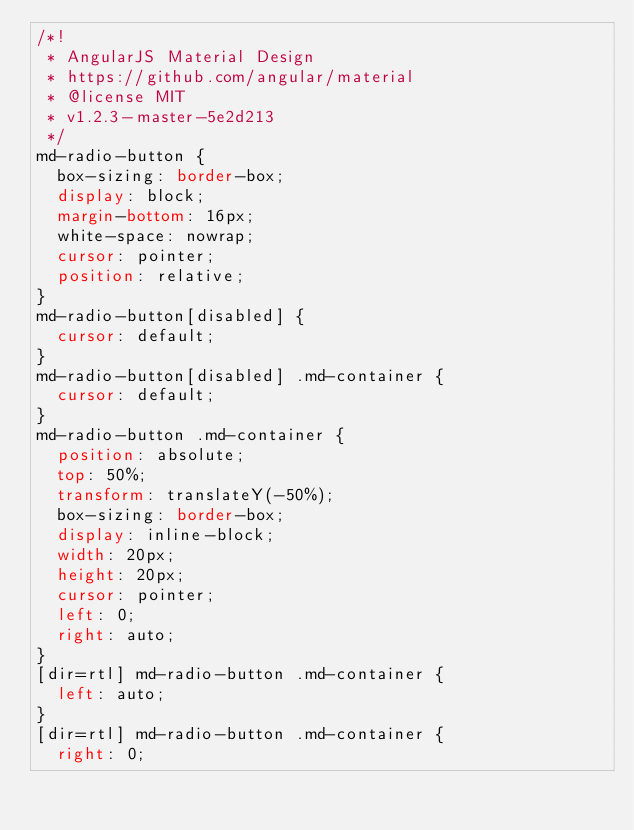Convert code to text. <code><loc_0><loc_0><loc_500><loc_500><_CSS_>/*!
 * AngularJS Material Design
 * https://github.com/angular/material
 * @license MIT
 * v1.2.3-master-5e2d213
 */
md-radio-button {
  box-sizing: border-box;
  display: block;
  margin-bottom: 16px;
  white-space: nowrap;
  cursor: pointer;
  position: relative;
}
md-radio-button[disabled] {
  cursor: default;
}
md-radio-button[disabled] .md-container {
  cursor: default;
}
md-radio-button .md-container {
  position: absolute;
  top: 50%;
  transform: translateY(-50%);
  box-sizing: border-box;
  display: inline-block;
  width: 20px;
  height: 20px;
  cursor: pointer;
  left: 0;
  right: auto;
}
[dir=rtl] md-radio-button .md-container {
  left: auto;
}
[dir=rtl] md-radio-button .md-container {
  right: 0;</code> 